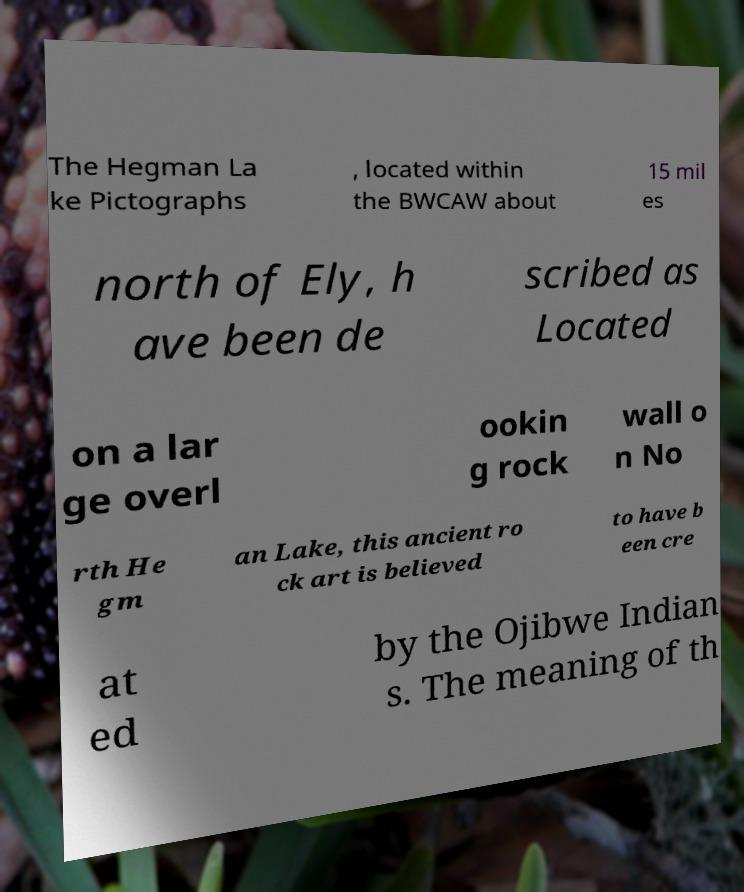Please identify and transcribe the text found in this image. The Hegman La ke Pictographs , located within the BWCAW about 15 mil es north of Ely, h ave been de scribed as Located on a lar ge overl ookin g rock wall o n No rth He gm an Lake, this ancient ro ck art is believed to have b een cre at ed by the Ojibwe Indian s. The meaning of th 